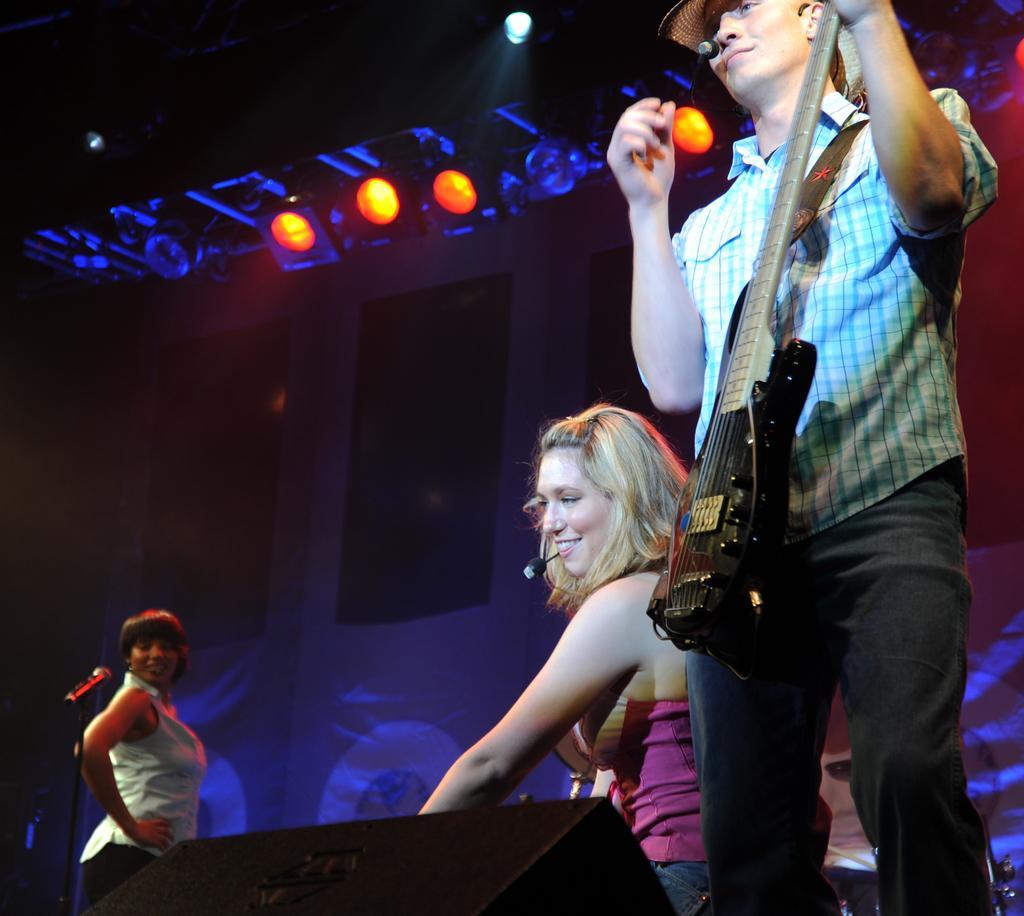Can you describe this image briefly? In this image there is a man standing and playing guitar, another woman sitting, another woman standing near a microphone, at the back ground there is screen and lights. 